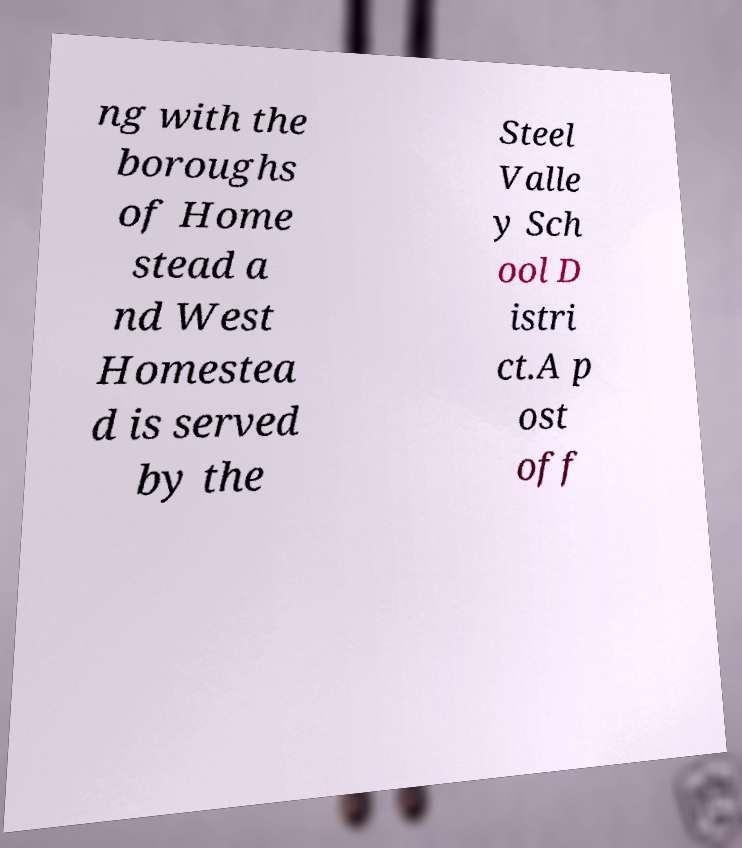For documentation purposes, I need the text within this image transcribed. Could you provide that? ng with the boroughs of Home stead a nd West Homestea d is served by the Steel Valle y Sch ool D istri ct.A p ost off 